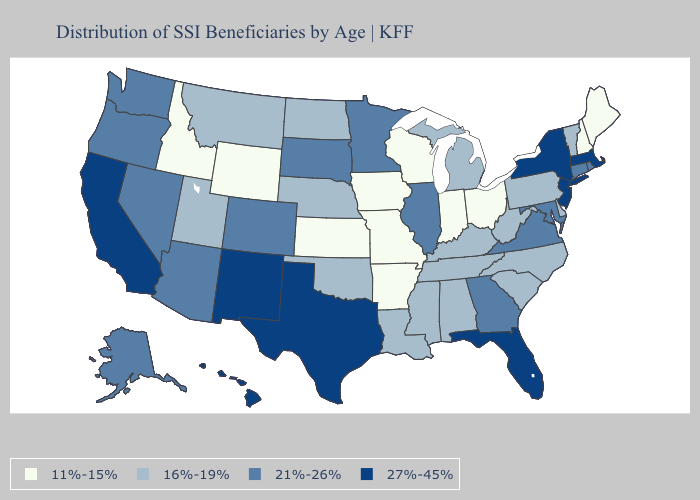Which states have the highest value in the USA?
Write a very short answer. California, Florida, Hawaii, Massachusetts, New Jersey, New Mexico, New York, Texas. Does California have the lowest value in the USA?
Write a very short answer. No. What is the highest value in the West ?
Concise answer only. 27%-45%. What is the value of Kansas?
Give a very brief answer. 11%-15%. What is the lowest value in states that border New Hampshire?
Answer briefly. 11%-15%. Is the legend a continuous bar?
Answer briefly. No. Among the states that border Texas , does New Mexico have the highest value?
Keep it brief. Yes. Among the states that border Minnesota , which have the highest value?
Quick response, please. South Dakota. Does the first symbol in the legend represent the smallest category?
Short answer required. Yes. Does Massachusetts have a higher value than California?
Be succinct. No. What is the lowest value in the South?
Quick response, please. 11%-15%. Is the legend a continuous bar?
Concise answer only. No. What is the value of West Virginia?
Keep it brief. 16%-19%. Does Oregon have the highest value in the West?
Concise answer only. No. What is the value of Alabama?
Give a very brief answer. 16%-19%. 